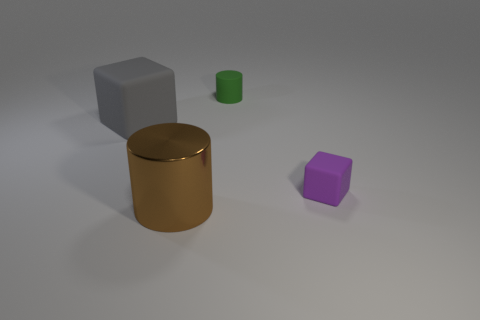Could the lighting in the image provide any clues about the environment? Yes, the lighting in the image suggests a soft, diffuse light source, creating gentle shadows and a calm atmosphere. The lack of harsh shadows or bright highlights implies either an overcast sky or ambient light in an indoor setting. The light doesn't define a clear direction, indicating that it's not a direct light like sunlight or a focused lamp. 